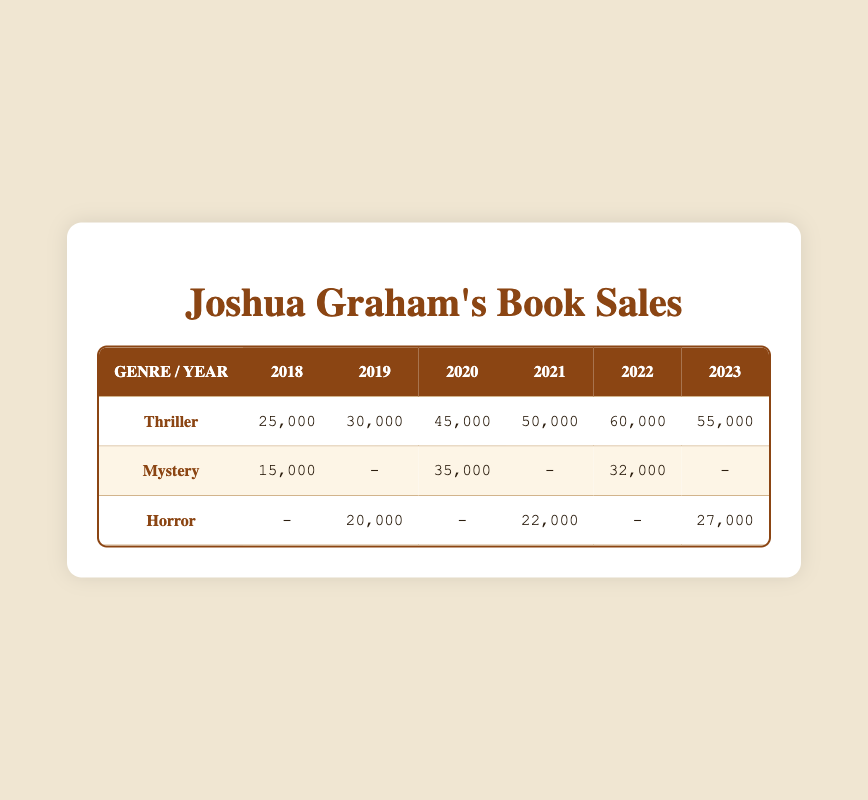What were the book sales for the Thriller genre in 2020? The table shows the sales figures for the Thriller genre in 2020, which is 45,000.
Answer: 45,000 How many books were sold in the Mystery genre in 2019? In the table, the sales figures for the Mystery genre in 2019 is listed as "-", indicating no sales were reported for that year.
Answer: No sales reported What was the total number of sales for the Horror genre across all years presented? By summing the sales for the Horror genre: 20,000 (2019) + 22,000 (2021) + 27,000 (2023) = 69,000.
Answer: 69,000 Did the sales for the Thriller genre increase every year? The sales figures for the Thriller genre were 25,000 (2018), 30,000 (2019), 45,000 (2020), 50,000 (2021), 60,000 (2022), and 55,000 (2023). The second to last year (2023) showed a decrease from the previous year (2022), so it's false that it increased every year.
Answer: No What is the difference in sales between the Thriller genre in 2022 and the Mystery genre in 2020? The Thriller genre sold 60,000 in 2022 and the Mystery genre sold 35,000 in 2020. The difference calculated is 60,000 - 35,000 = 25,000.
Answer: 25,000 Which genre had the highest sales in 2021? Looking at the table, the sales for 2021 show that the Thriller genre had 50,000, while the Horror genre had 22,000, meaning the Thriller genre had the highest sales for that year.
Answer: Thriller What was the average sales for the Mystery genre across the years where data is available? The sales for Mystery are 15,000 (2018), 35,000 (2020), and 32,000 (2022). Calculating the average: (15,000 + 35,000 + 32,000) / 3 = 27,333.
Answer: 27,333 Did any genre see no sales in 2018? The table indicates that in 2018, sales for the Thriller and Mystery genres were reported (25,000 and 15,000 respectively), while Horror showed no sales ("-"). Therefore, yes, the Horror genre saw no sales in 2018.
Answer: Yes 